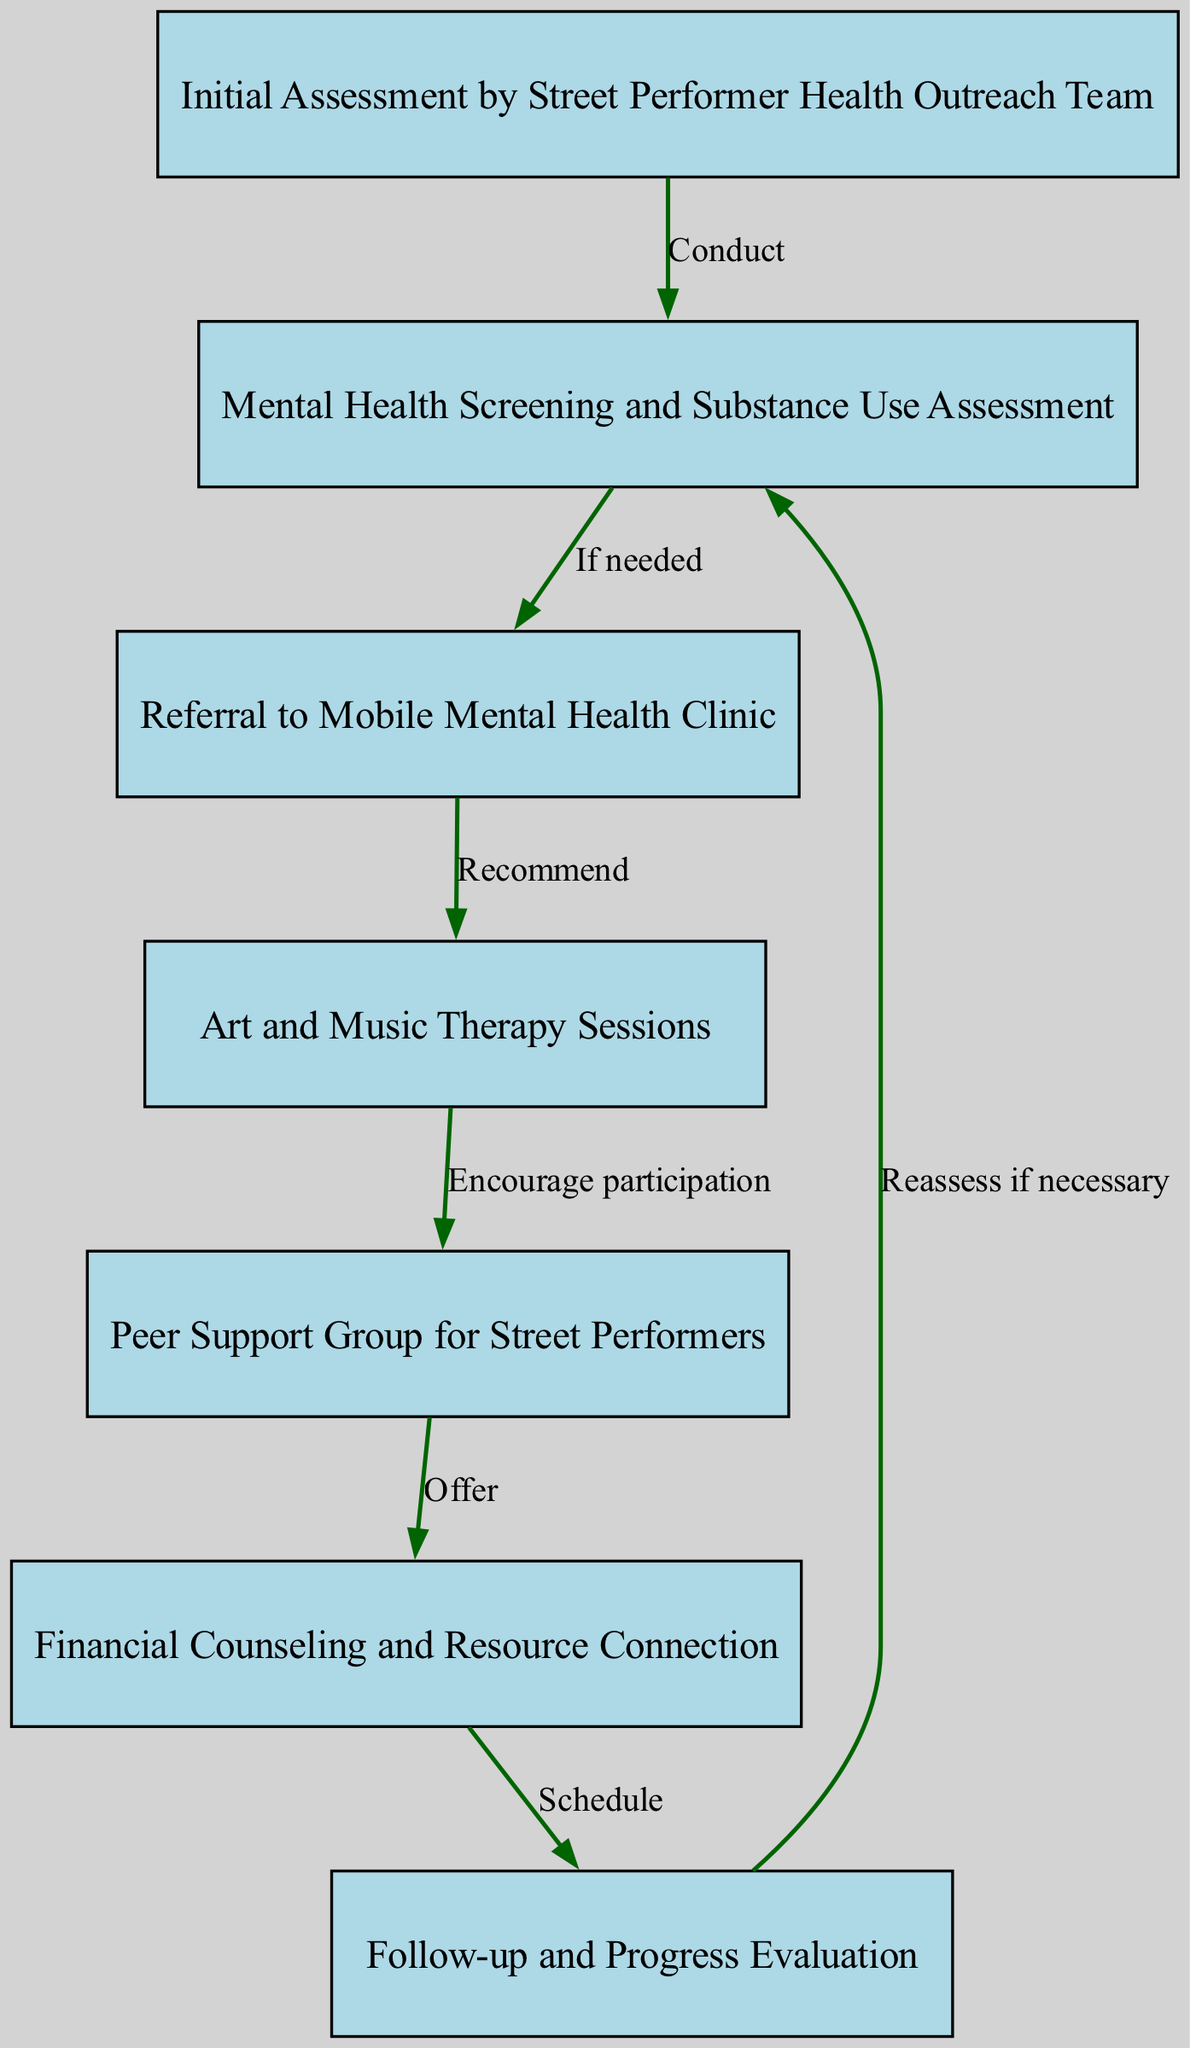What is the first step in the pathway? The first node in the diagram is 'Initial Assessment by Street Performer Health Outreach Team', indicating this is where the process begins.
Answer: Initial Assessment by Street Performer Health Outreach Team How many nodes are in the diagram? By counting the nodes listed, there are a total of seven distinct steps in the pathway.
Answer: 7 What does the referral step lead to? The 'Referral to Mobile Mental Health Clinic' node connects to 'Art and Music Therapy Sessions', showing the flow from one to the other.
Answer: Art and Music Therapy Sessions What action follows the screening step? After the 'Mental Health Screening and Substance Use Assessment' node, the next action is a 'Referral to Mobile Mental Health Clinic' if needed, indicating a conditional flow.
Answer: Referral to Mobile Mental Health Clinic Which node encourages participation in another step? The node 'Art and Music Therapy Sessions' has an outgoing edge that encourages participation in the 'Peer Support Group for Street Performers', indicating a recommendation.
Answer: Peer Support Group for Street Performers What is the last node in the pathway? The final node in the sequence is 'Follow-up and Progress Evaluation', which concludes the clinical pathway process.
Answer: Follow-up and Progress Evaluation How does the 'Financial Counseling and Resource Connection' node connect to the diagram? The 'Financial Counseling and Resource Connection' node follows from the 'Peer Support Group for Street Performers', demonstrating its connection as an additional support resource after peer interactions.
Answer: Schedule 